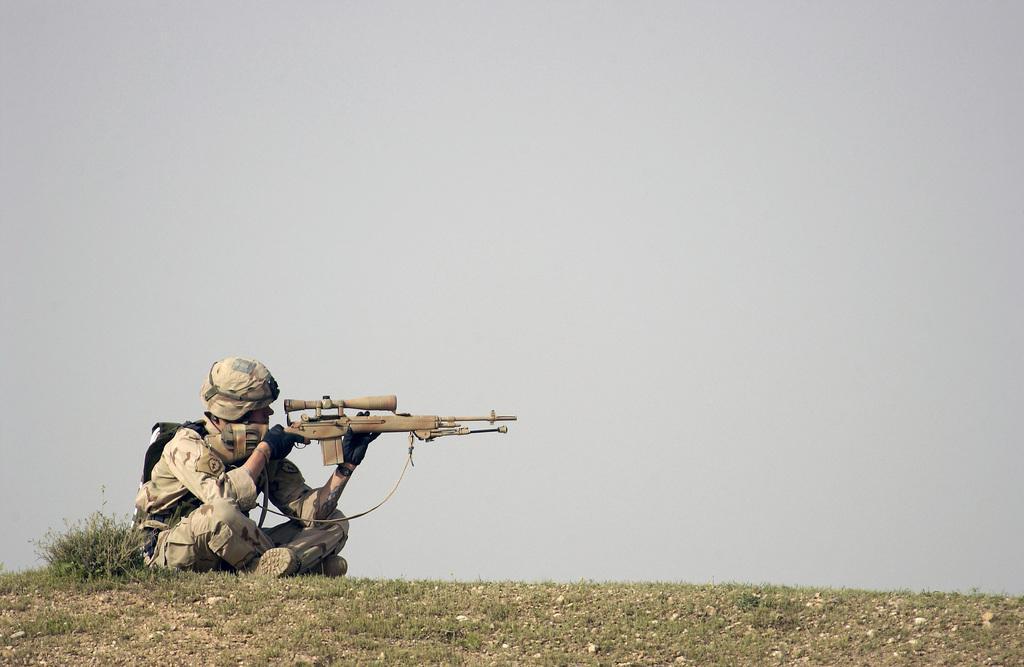Can you describe this image briefly? There is a person sitting on the ground. He is wearing gloves, cap and a bag. Also he is holding a gun. On the ground there is grass. In the background there is sky. 